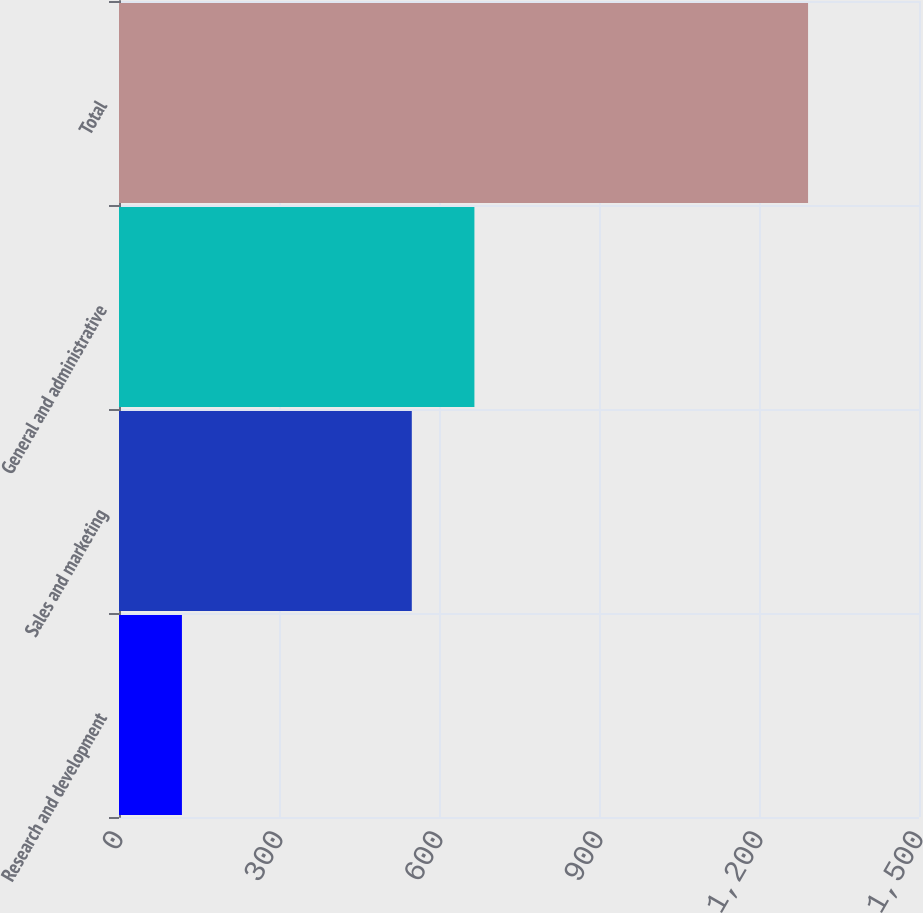Convert chart. <chart><loc_0><loc_0><loc_500><loc_500><bar_chart><fcel>Research and development<fcel>Sales and marketing<fcel>General and administrative<fcel>Total<nl><fcel>118<fcel>549<fcel>666.4<fcel>1292<nl></chart> 